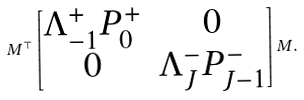<formula> <loc_0><loc_0><loc_500><loc_500>M ^ { \top } \begin{bmatrix} { \Lambda _ { - 1 } ^ { + } } P _ { 0 } ^ { + } & 0 \\ 0 & { \Lambda _ { J } ^ { - } } P _ { J - 1 } ^ { - } \end{bmatrix} M .</formula> 